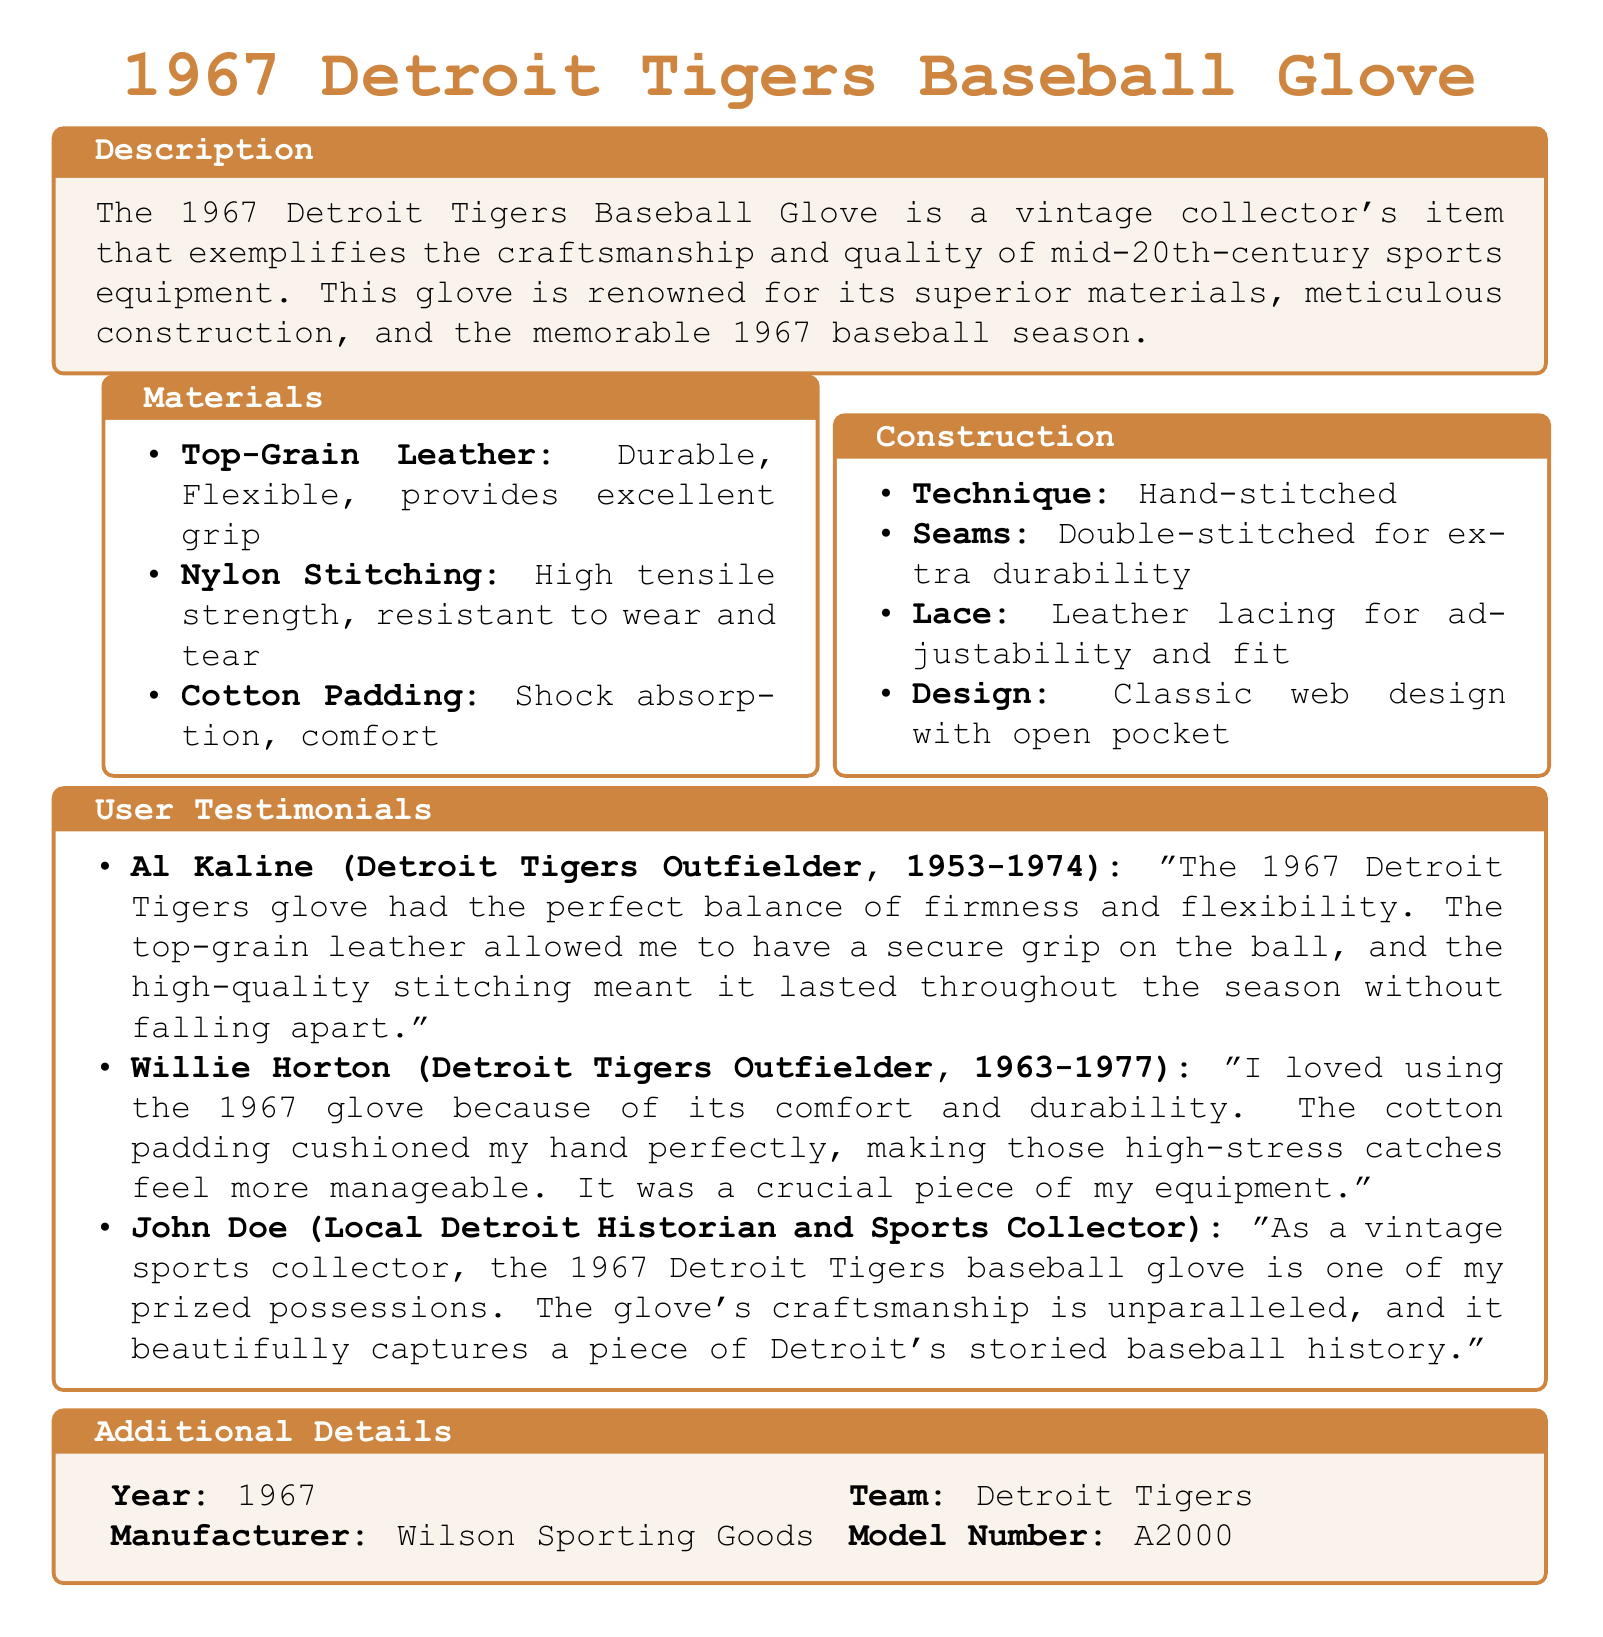What materials are used in the glove? The materials listed in the document are top-grain leather, nylon stitching, and cotton padding.
Answer: Top-grain leather, nylon stitching, cotton padding What type of stitching is used in the construction? The document specifies that the glove is hand-stitched.
Answer: Hand-stitched Who was the manufacturer of the glove? The manufacturer of the glove is mentioned in the additional details section.
Answer: Wilson Sporting Goods What year was the glove created? The year is provided in the additional details section.
Answer: 1967 What did Al Kaline say about the glove? Al Kaline's testimonial reveals his opinion about the glove's grip and stitching quality.
Answer: Perfect balance of firmness and flexibility What is the model number of the glove? The model number can be found in the additional details section.
Answer: A2000 Which team is associated with the glove? The associated team is mentioned in the additional details section of the document.
Answer: Detroit Tigers What feature provides shock absorption in the glove? The type of padding specified for comfort and shock absorption is mentioned in the materials section.
Answer: Cotton Padding What design feature does the glove have? The construction section describes a specific design characteristic of the glove.
Answer: Classic web design with open pocket 